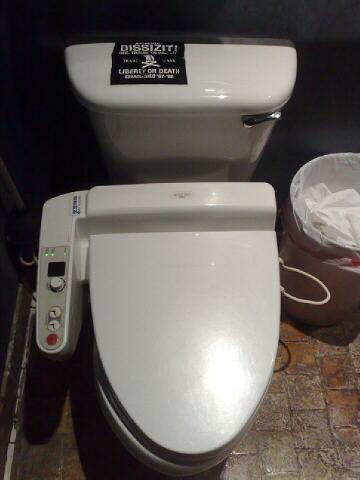Extract all visible text content from this image. DISSIZIT DEATH 